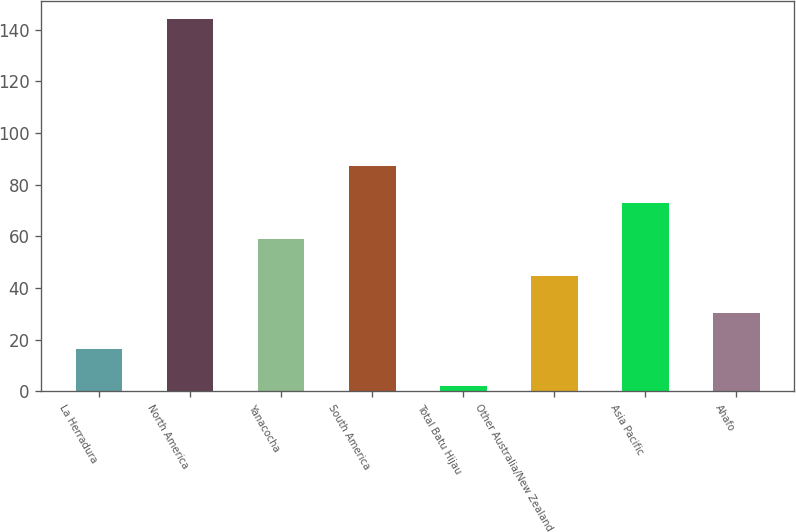Convert chart to OTSL. <chart><loc_0><loc_0><loc_500><loc_500><bar_chart><fcel>La Herradura<fcel>North America<fcel>Yanacocha<fcel>South America<fcel>Total Batu Hijau<fcel>Other Australia/New Zealand<fcel>Asia Pacific<fcel>Ahafo<nl><fcel>16.2<fcel>144<fcel>58.8<fcel>87.2<fcel>2<fcel>44.6<fcel>73<fcel>30.4<nl></chart> 